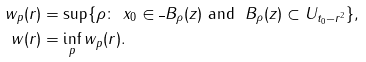<formula> <loc_0><loc_0><loc_500><loc_500>w _ { p } ( r ) & = \sup \{ \rho \colon \ x _ { 0 } \in \overline { \ } B _ { \rho } ( z ) \ \text {and} \ \ B _ { \rho } ( z ) \subset U _ { t _ { 0 } - r ^ { 2 } } \} , \\ w ( r ) & = \inf _ { p } w _ { p } ( r ) .</formula> 